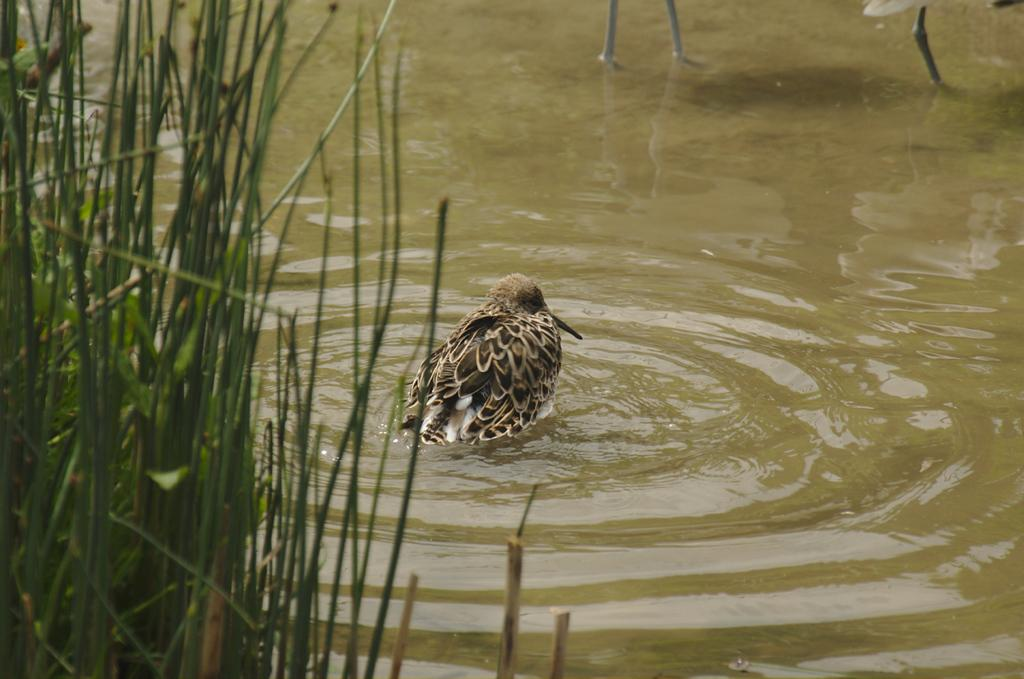What is located in the foreground of the image? There are plants in the foreground of the image. What can be seen in the background of the image? There is a bird in the water in the background of the image. What type of industry can be seen in the image? There is no industry present in the image; it features plants in the foreground and a bird in the water in the background. How does the bird in the water make you feel? The image does not convey any feelings or emotions, as it is a static representation of the scene. 